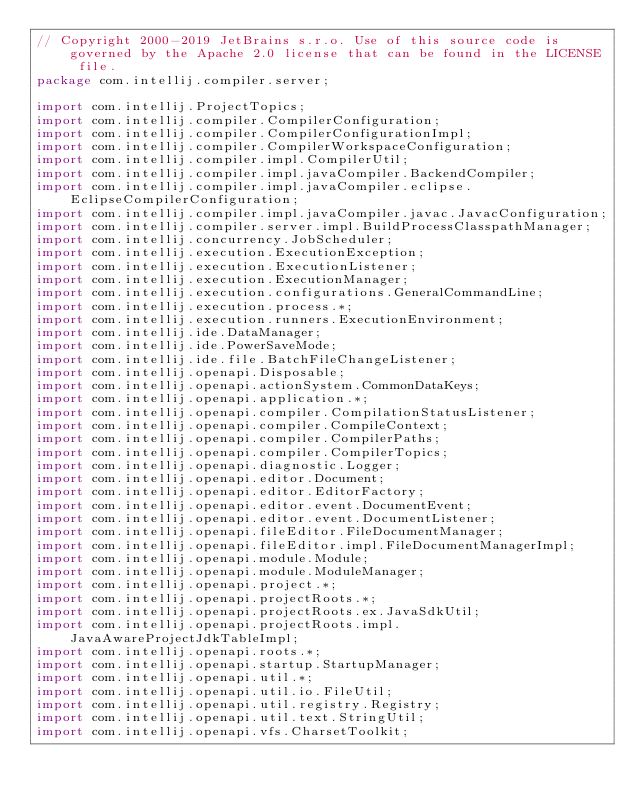Convert code to text. <code><loc_0><loc_0><loc_500><loc_500><_Java_>// Copyright 2000-2019 JetBrains s.r.o. Use of this source code is governed by the Apache 2.0 license that can be found in the LICENSE file.
package com.intellij.compiler.server;

import com.intellij.ProjectTopics;
import com.intellij.compiler.CompilerConfiguration;
import com.intellij.compiler.CompilerConfigurationImpl;
import com.intellij.compiler.CompilerWorkspaceConfiguration;
import com.intellij.compiler.impl.CompilerUtil;
import com.intellij.compiler.impl.javaCompiler.BackendCompiler;
import com.intellij.compiler.impl.javaCompiler.eclipse.EclipseCompilerConfiguration;
import com.intellij.compiler.impl.javaCompiler.javac.JavacConfiguration;
import com.intellij.compiler.server.impl.BuildProcessClasspathManager;
import com.intellij.concurrency.JobScheduler;
import com.intellij.execution.ExecutionException;
import com.intellij.execution.ExecutionListener;
import com.intellij.execution.ExecutionManager;
import com.intellij.execution.configurations.GeneralCommandLine;
import com.intellij.execution.process.*;
import com.intellij.execution.runners.ExecutionEnvironment;
import com.intellij.ide.DataManager;
import com.intellij.ide.PowerSaveMode;
import com.intellij.ide.file.BatchFileChangeListener;
import com.intellij.openapi.Disposable;
import com.intellij.openapi.actionSystem.CommonDataKeys;
import com.intellij.openapi.application.*;
import com.intellij.openapi.compiler.CompilationStatusListener;
import com.intellij.openapi.compiler.CompileContext;
import com.intellij.openapi.compiler.CompilerPaths;
import com.intellij.openapi.compiler.CompilerTopics;
import com.intellij.openapi.diagnostic.Logger;
import com.intellij.openapi.editor.Document;
import com.intellij.openapi.editor.EditorFactory;
import com.intellij.openapi.editor.event.DocumentEvent;
import com.intellij.openapi.editor.event.DocumentListener;
import com.intellij.openapi.fileEditor.FileDocumentManager;
import com.intellij.openapi.fileEditor.impl.FileDocumentManagerImpl;
import com.intellij.openapi.module.Module;
import com.intellij.openapi.module.ModuleManager;
import com.intellij.openapi.project.*;
import com.intellij.openapi.projectRoots.*;
import com.intellij.openapi.projectRoots.ex.JavaSdkUtil;
import com.intellij.openapi.projectRoots.impl.JavaAwareProjectJdkTableImpl;
import com.intellij.openapi.roots.*;
import com.intellij.openapi.startup.StartupManager;
import com.intellij.openapi.util.*;
import com.intellij.openapi.util.io.FileUtil;
import com.intellij.openapi.util.registry.Registry;
import com.intellij.openapi.util.text.StringUtil;
import com.intellij.openapi.vfs.CharsetToolkit;</code> 